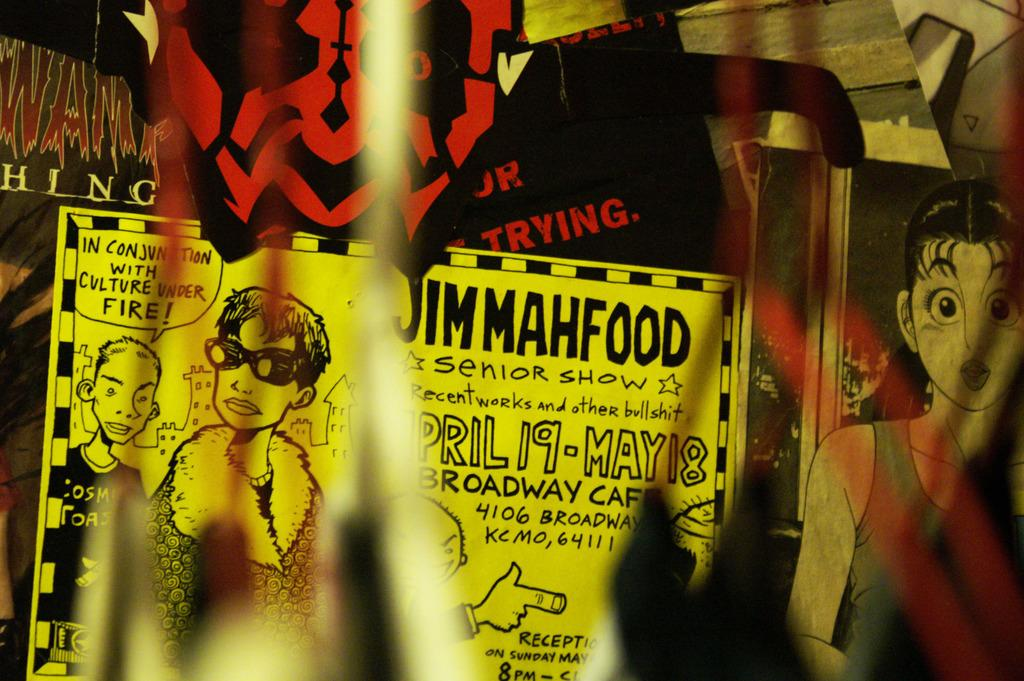What is the main subject of the picture? The main subject of the picture is a sheet with images and writing. Are there any other visual elements in the picture? Yes, there are other images on the wall in the picture. How does the family get into trouble in the picture? There is no family present in the picture, nor is there any indication of trouble. 